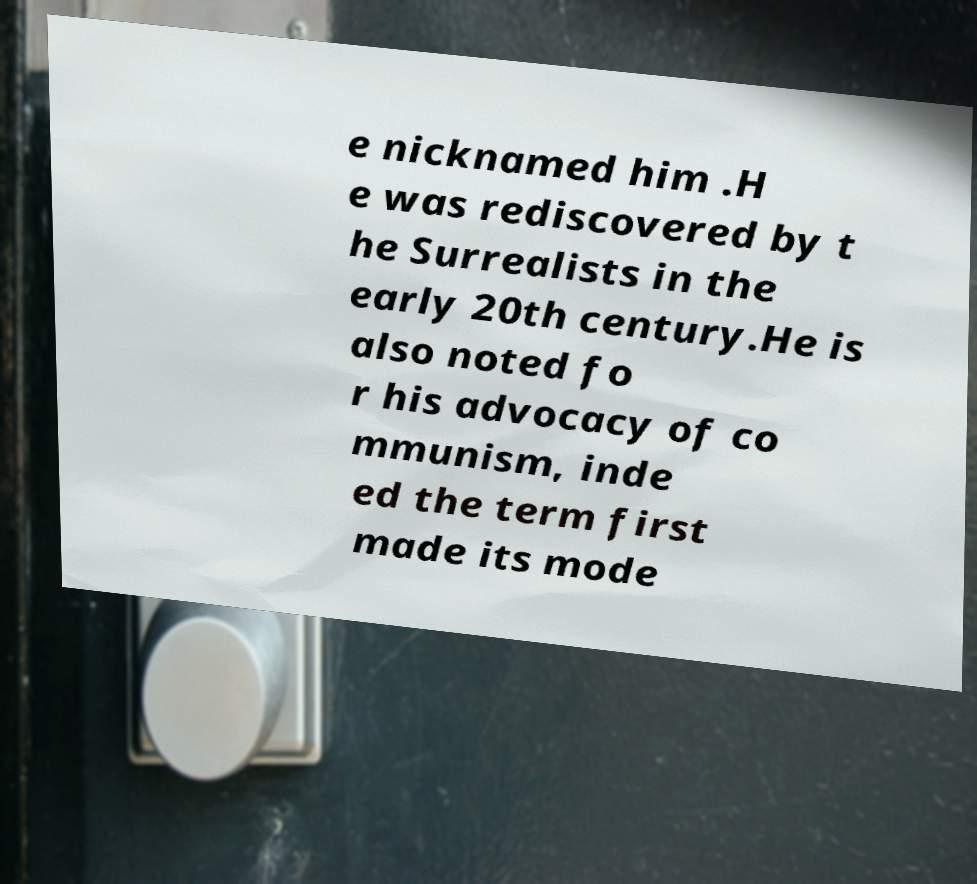What messages or text are displayed in this image? I need them in a readable, typed format. e nicknamed him .H e was rediscovered by t he Surrealists in the early 20th century.He is also noted fo r his advocacy of co mmunism, inde ed the term first made its mode 